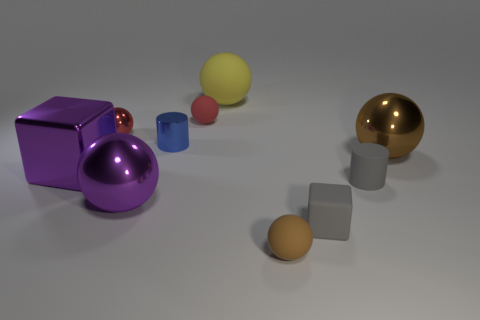What number of other things are there of the same color as the small metallic cylinder?
Give a very brief answer. 0. How many yellow things are matte cubes or metal spheres?
Your response must be concise. 0. There is a big metal object to the right of the big matte ball; is its shape the same as the tiny rubber object on the left side of the large yellow ball?
Offer a terse response. Yes. How many other objects are there of the same material as the big yellow thing?
Provide a succinct answer. 4. Are there any cubes that are behind the cylinder on the right side of the tiny rubber thing that is to the left of the tiny brown sphere?
Ensure brevity in your answer.  Yes. Is the material of the small brown object the same as the gray cylinder?
Provide a succinct answer. Yes. What is the material of the small cylinder behind the large metallic object right of the big rubber ball?
Offer a terse response. Metal. There is a cylinder in front of the metal cylinder; what size is it?
Offer a terse response. Small. There is a thing that is in front of the red shiny sphere and to the left of the purple metallic ball; what color is it?
Give a very brief answer. Purple. Do the cube right of the blue metal cylinder and the small red rubber ball have the same size?
Your answer should be compact. Yes. 